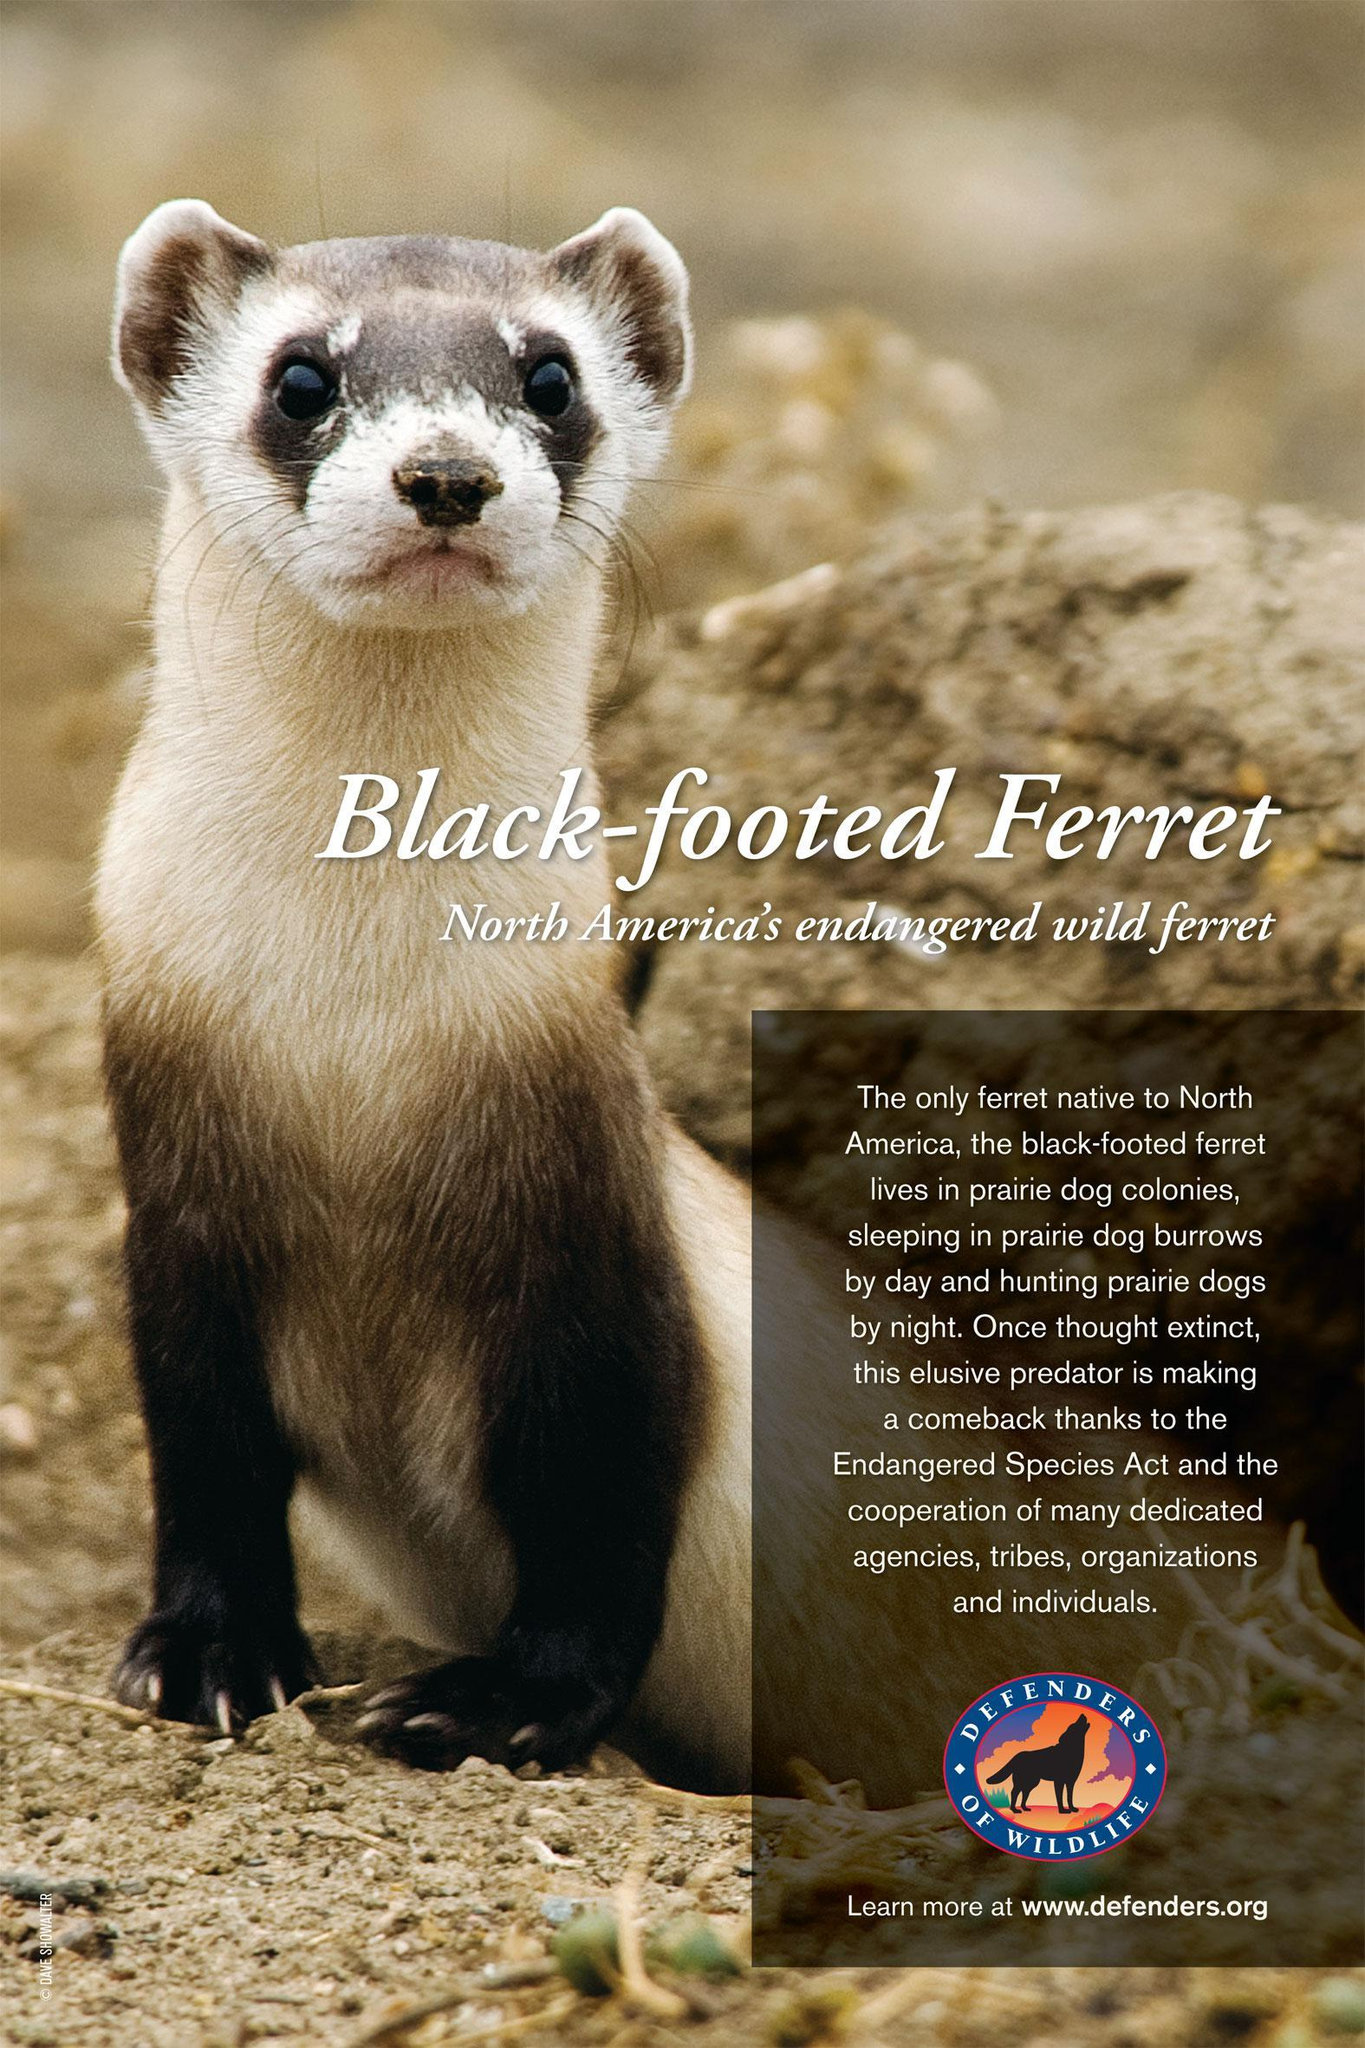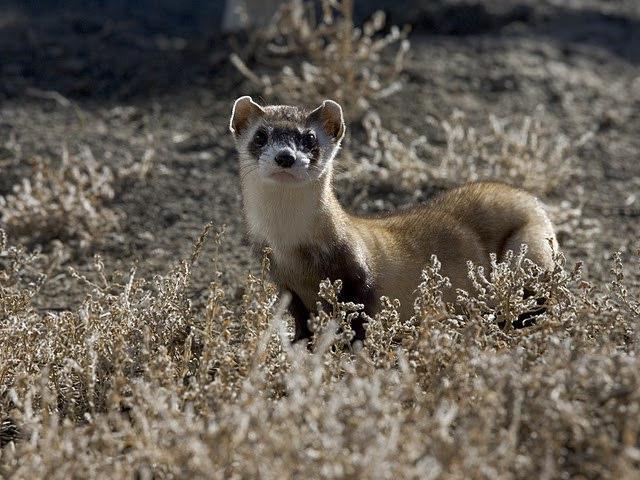The first image is the image on the left, the second image is the image on the right. Assess this claim about the two images: "At one image shows a group of at least three ferrets inside a brightly colored blue box with white nesting material.". Correct or not? Answer yes or no. No. The first image is the image on the left, the second image is the image on the right. For the images shown, is this caption "The left image contains at least two ferrets." true? Answer yes or no. No. 